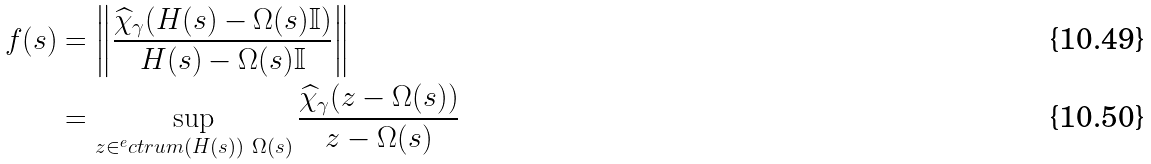<formula> <loc_0><loc_0><loc_500><loc_500>f ( s ) & = \left \| \frac { \widehat { \chi } _ { \gamma } ( H ( s ) - \Omega ( s ) \mathbb { I } ) } { H ( s ) - \Omega ( s ) \mathbb { I } } \right \| \\ & = \sup _ { z \in ^ { e } c t r u m ( H ( s ) ) \ \Omega ( s ) } \frac { \widehat { \chi } _ { \gamma } ( z - \Omega ( s ) ) } { z - \Omega ( s ) }</formula> 